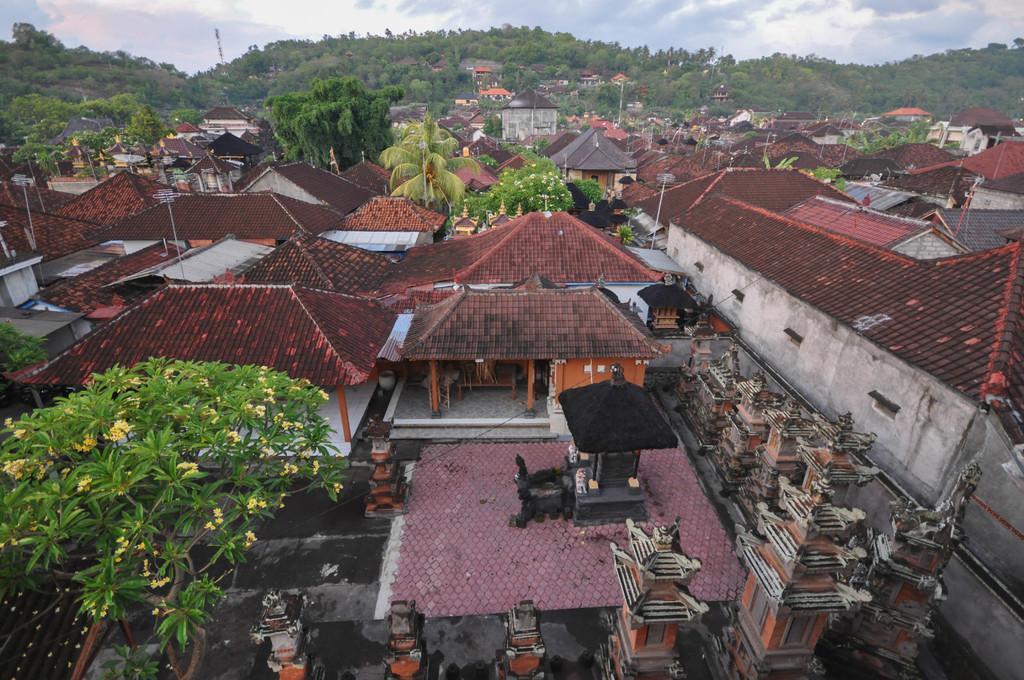Describe this image in one or two sentences. In the foreground area of this image there are houses, trees and poles. There is greenery and sky in the background area 